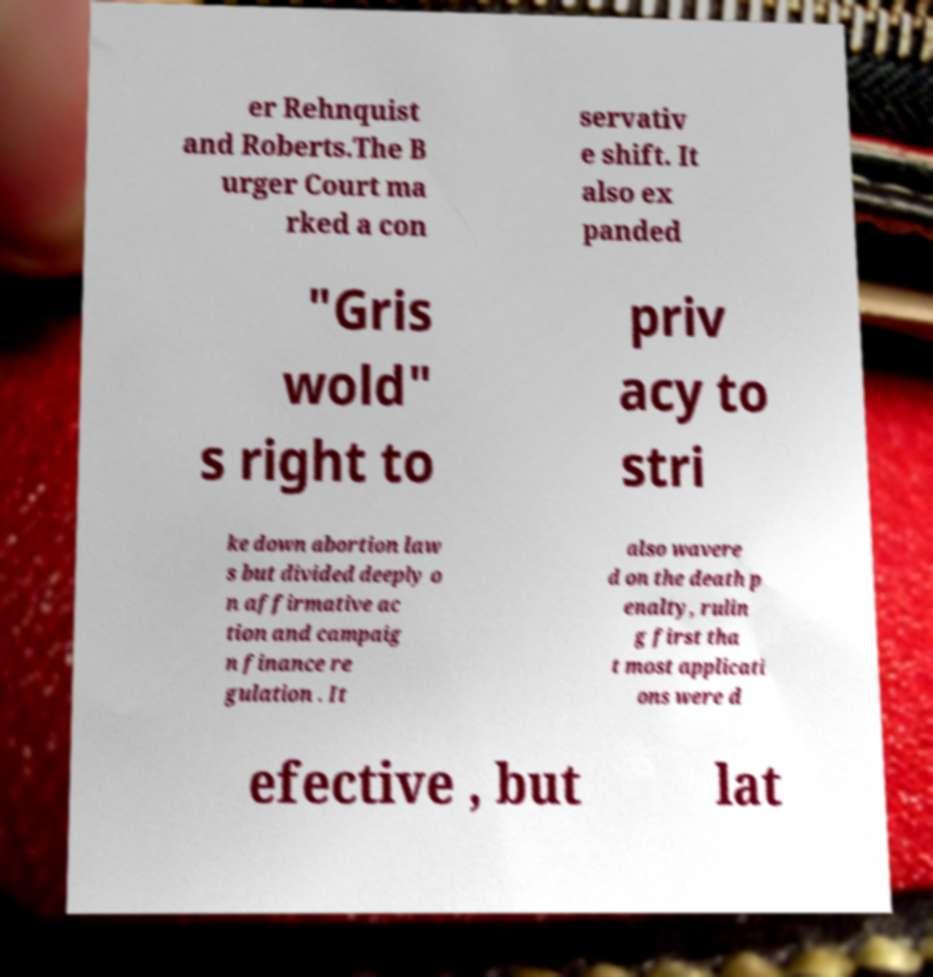Can you read and provide the text displayed in the image?This photo seems to have some interesting text. Can you extract and type it out for me? er Rehnquist and Roberts.The B urger Court ma rked a con servativ e shift. It also ex panded "Gris wold" s right to priv acy to stri ke down abortion law s but divided deeply o n affirmative ac tion and campaig n finance re gulation . It also wavere d on the death p enalty, rulin g first tha t most applicati ons were d efective , but lat 